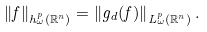<formula> <loc_0><loc_0><loc_500><loc_500>\left \| f \right \| _ { h _ { \omega } ^ { p } ( \mathbb { R } ^ { n } ) } = \left \| g _ { d } ( f ) \right \| _ { L _ { \omega } ^ { p } ( \mathbb { R } ^ { n } ) } .</formula> 